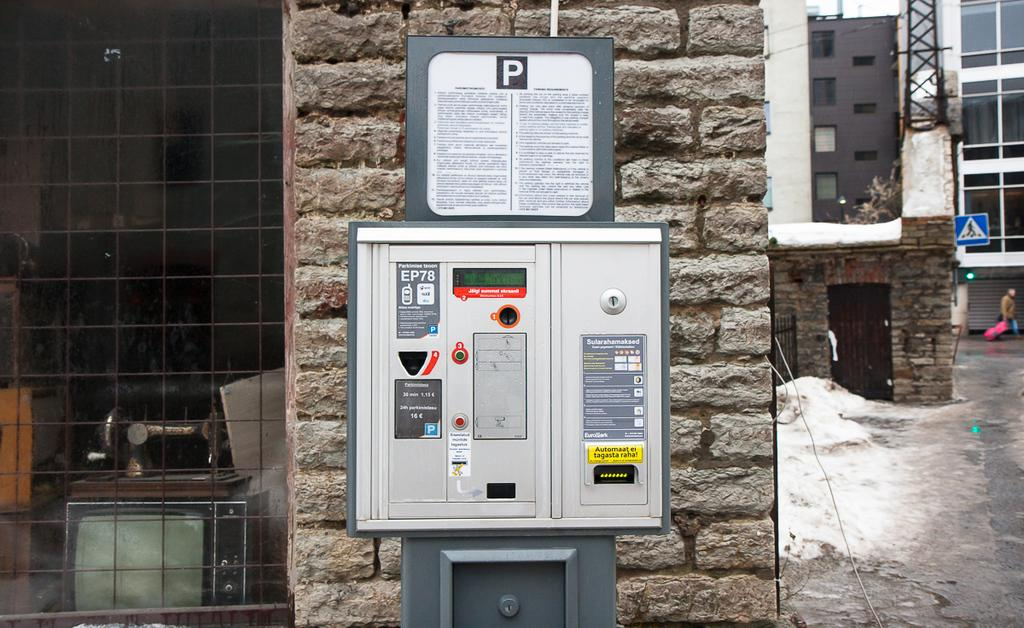Provide a one-sentence caption for the provided image. A brick column in an urban setting holds a metal electrical box with the letter "P" written across the top. 